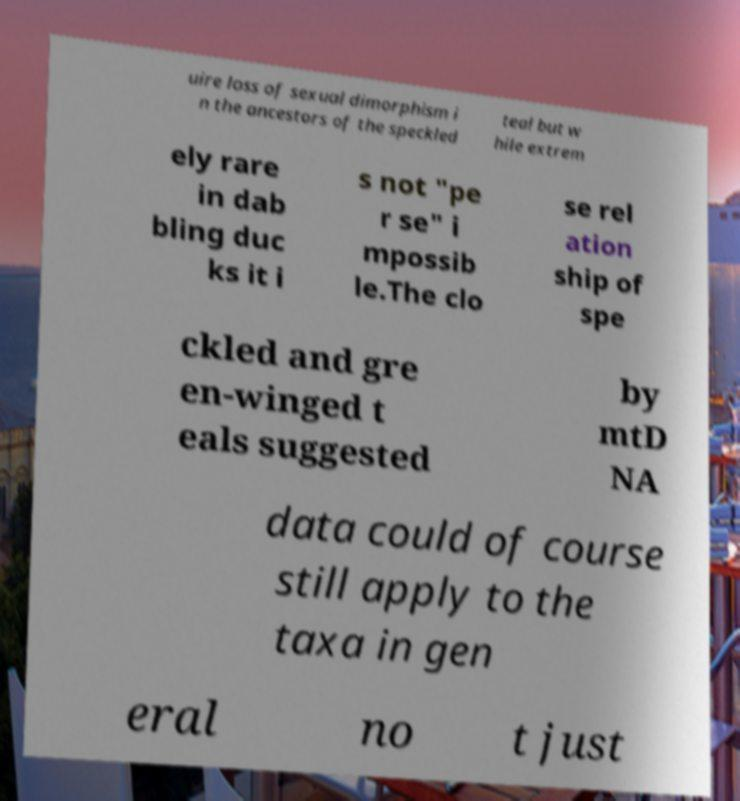There's text embedded in this image that I need extracted. Can you transcribe it verbatim? uire loss of sexual dimorphism i n the ancestors of the speckled teal but w hile extrem ely rare in dab bling duc ks it i s not "pe r se" i mpossib le.The clo se rel ation ship of spe ckled and gre en-winged t eals suggested by mtD NA data could of course still apply to the taxa in gen eral no t just 